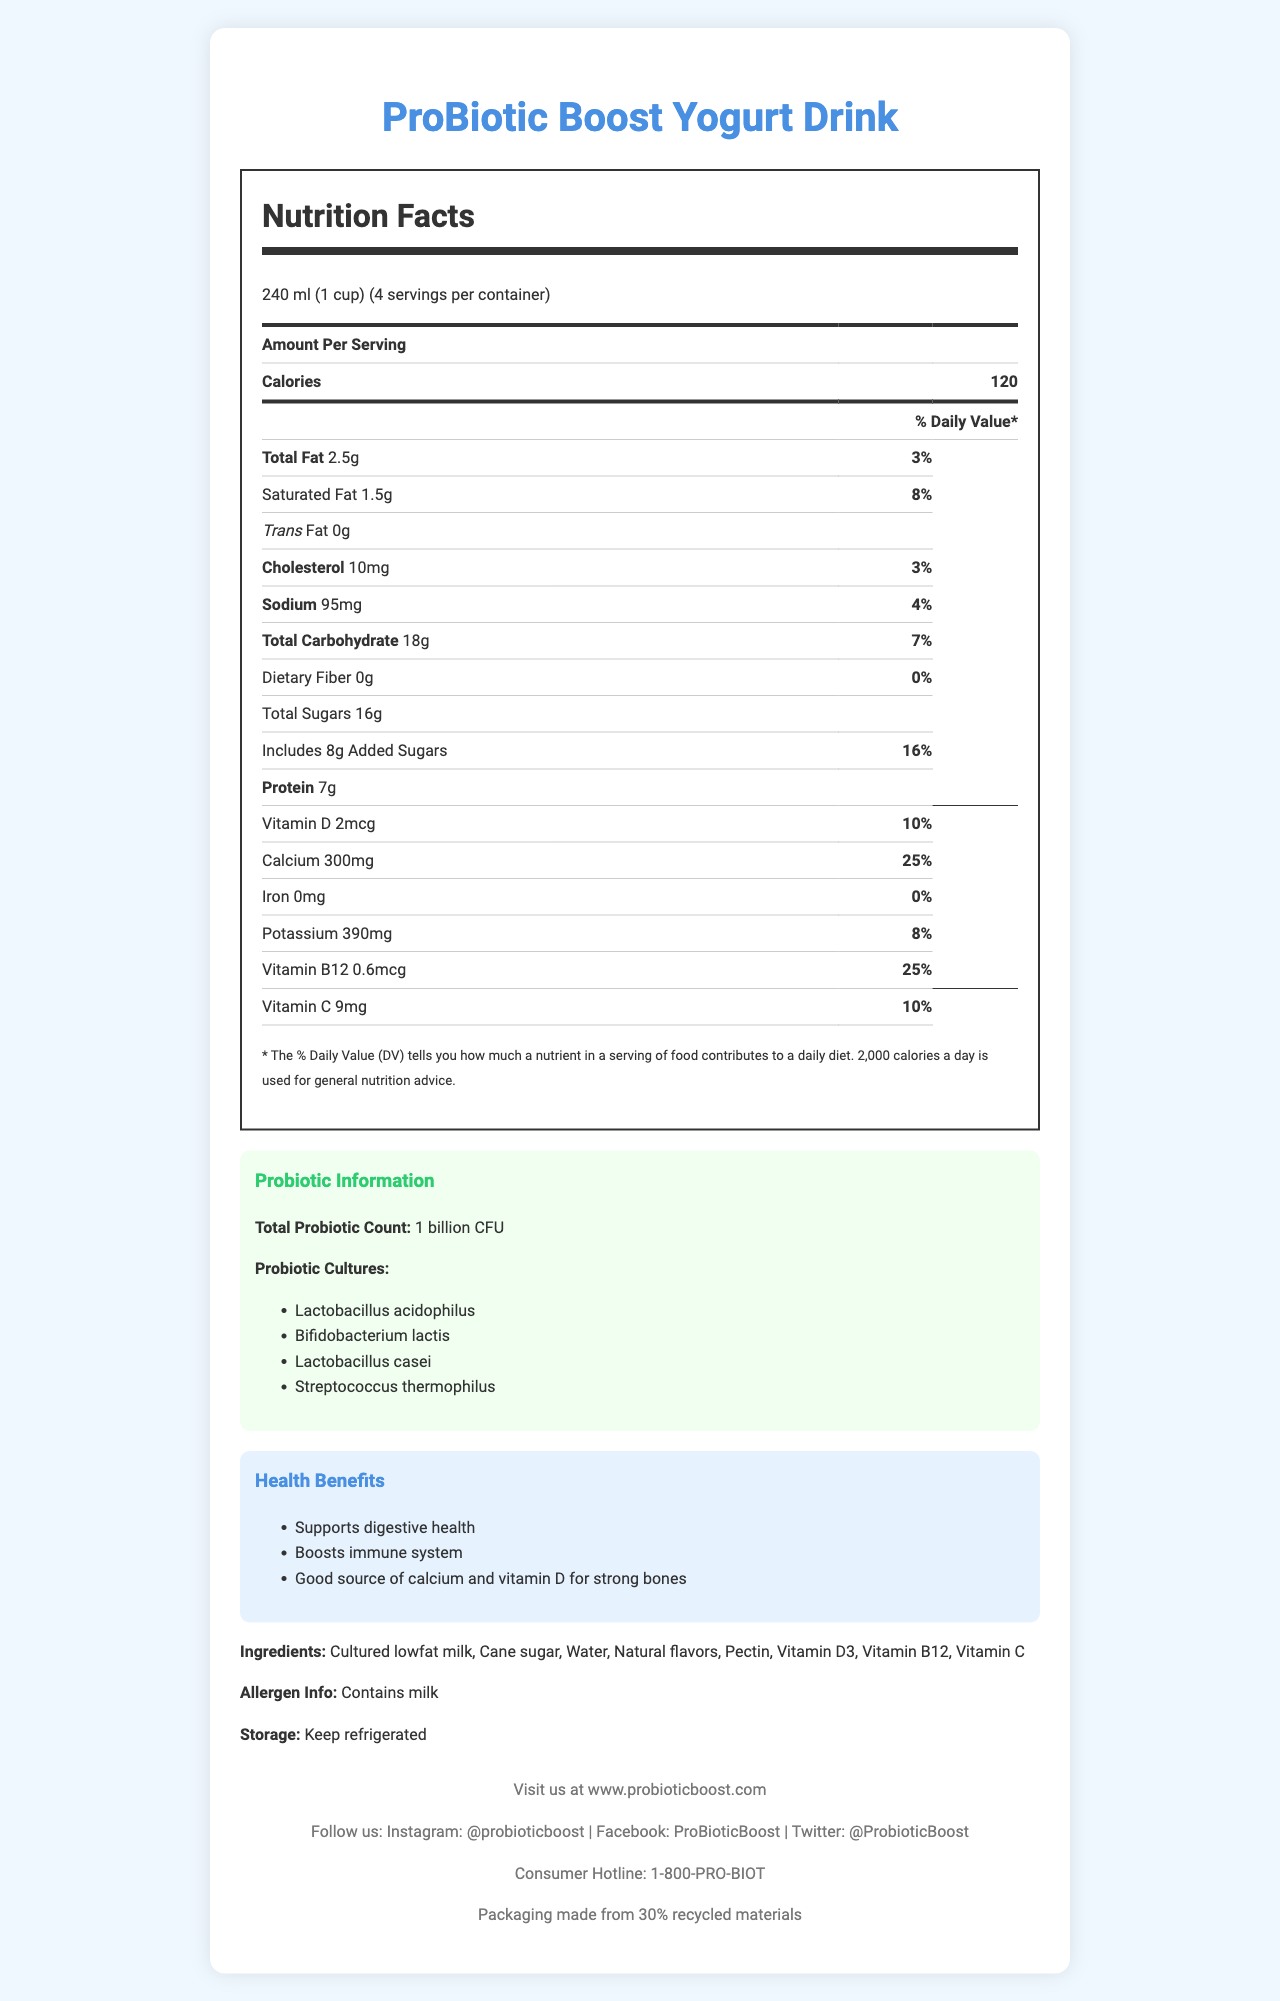what is the serving size for ProBiotic Boost Yogurt Drink? The serving size is listed right at the top of the Nutrition Facts section as "240 ml (1 cup)".
Answer: 240 ml (1 cup) how many calories are in one serving of the yogurt drink? The calories per serving are shown directly under the serving size in the Nutrition Facts section.
Answer: 120 what is the amount of saturated fat per serving? The amount of saturated fat is listed under the Total Fat category in the Nutrition Facts section.
Answer: 1.5g what is the percentage daily value of calcium provided by one serving? The percentage daily value of calcium is indicated as 25% in the Nutrition Facts section.
Answer: 25% how much protein does one serving contain? The protein content per serving is mentioned in the Nutrition Facts section.
Answer: 7g which live culture strains are included in the yogurt drink? The Probiotic Information section lists these live culture strains.
Answer: Lactobacillus acidophilus, Bifidobacterium lactis, Lactobacillus casei, Streptococcus thermophilus what are the health benefits associated with consuming this yogurt drink? The Health Benefits section provides these health claims.
Answer: Supports digestive health, Boosts immune system, Good source of calcium and vitamin D for strong bones where should you store the ProBiotic Boost Yogurt Drink? The storage instructions at the bottom indicate it should be kept refrigerated.
Answer: Keep refrigerated does the yogurt drink contain any trans fat? The Nutrition Facts section clearly states "Trans Fat 0g".
Answer: No what is the contact number for consumer inquiries? The footer of the document lists the consumer hotline as 1-800-PRO-BIOT.
Answer: 1-800-PRO-BIOT what is the total probiotic count in the yogurt drink? The Probiotic Information section states the total probiotic count is 1 billion CFU.
Answer: 1 billion CFU Identify the allergen in this yogurt drink. The allergen info at the bottom of the document mentions it contains milk.
Answer: milk what amount of added sugars is in one serving of the yogurt drink? The Nutrition Facts section states "Includes 8g Added Sugars".
Answer: 8g which vitamin has the highest daily value percentage in this yogurt drink? A. Vitamin D B. Vitamin B12 C. Vitamin C Vitamin B12 has a daily value of 25%, which is higher than Vitamin D (10%) and Vitamin C (10%).
Answer: B how many milligrams of potassium does a serving of this yogurt drink have? A. 200 mg B. 390 mg C. 500 mg The Nutrition Facts section lists 390mg of potassium per serving.
Answer: B is the yogurt drink a good source of vitamin C? One serving of the yogurt drink provides 10% of the daily value for Vitamin C, which qualifies as a good source.
Answer: Yes summarize the main idea of the document. The document provides comprehensive information on the nutritional content and health benefits of the ProBiotic Boost Yogurt Drink, along with storage and contact information.
Answer: ProBiotic Boost Yogurt Drink is a nutritious probiotic yogurt drink with live culture strains, added vitamins, and various health benefits. The document outlines detailed nutritional information, health claims, ingredients, storage instructions, and contact details. what is the source of the yogurt drink's sugar content? The ingredient list specifies that one of the ingredients is cane sugar, indicating the source of the yogurt drink's sugar content.
Answer: Cane sugar what is the brand's Instagram handle? A. @ProbioticBoost B. @probioticboost C. @Pro_Boost The footer lists the brand's Instagram handle as @probioticboost.
Answer: B how many servings are there per container of the yogurt drink? The Nutrition Facts section mentions that there are 4 servings per container.
Answer: 4 who can confirm the number of CFUs of probiotics in the yogurt? The document does not provide any verification details or methods for confirming the CFU count of probiotics.
Answer: Not enough information 